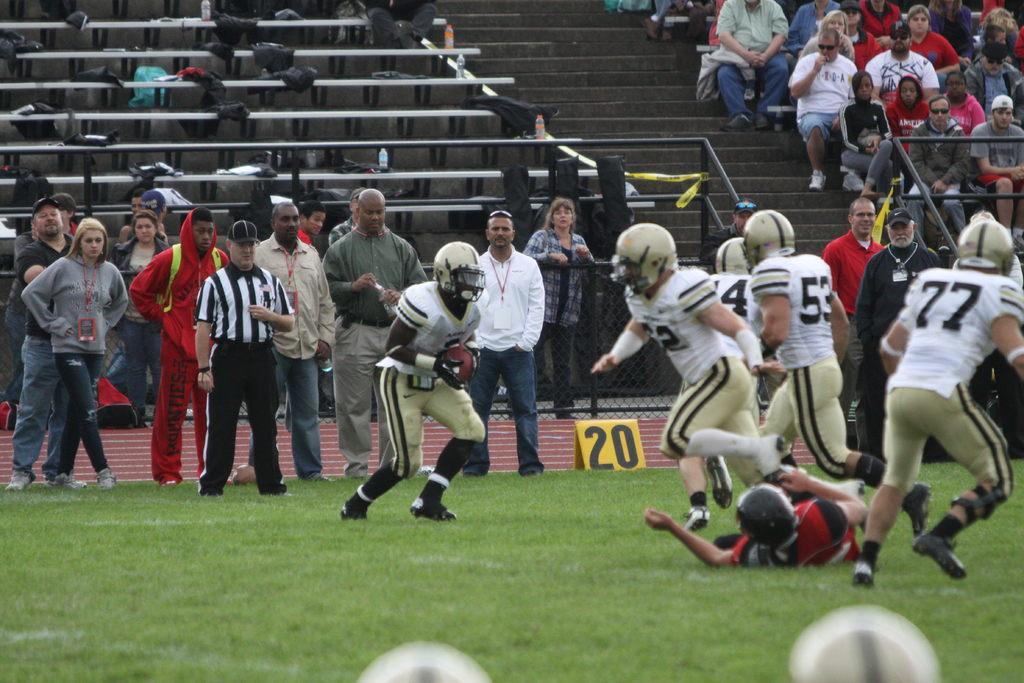In one or two sentences, can you explain what this image depicts? In this image we can see the players wearing the helmets and we can also see the balls, grass, number board and also the fence. We can also see the people standing. In the background we can see the people sitting in the stands. We can also see the stairs. 